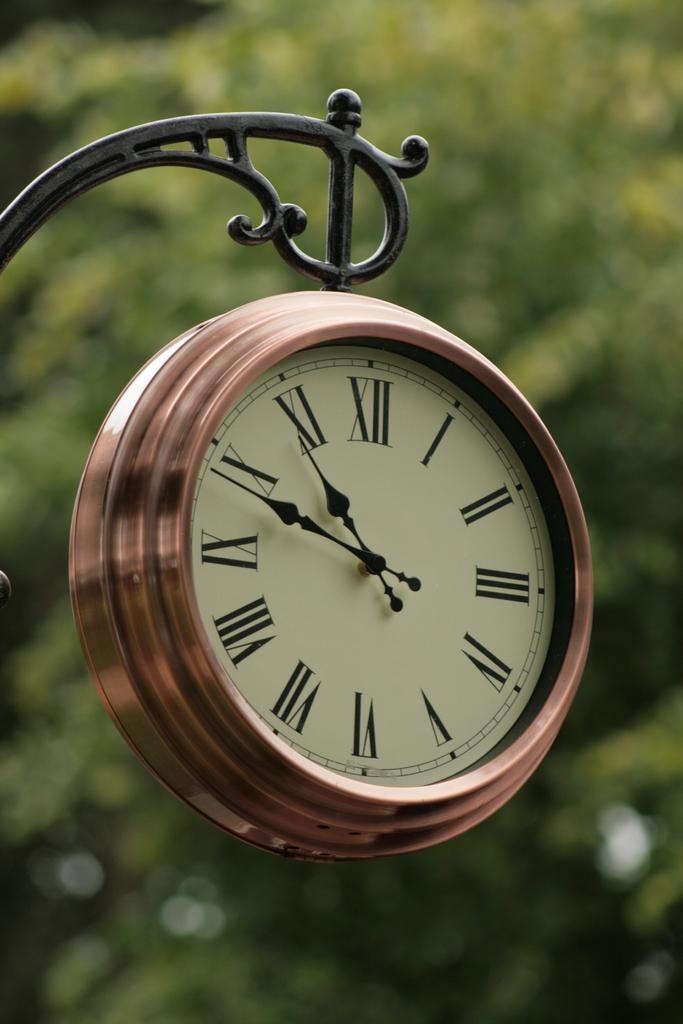Please provide a concise description of this image. In this image we can see a clock, hanging from a metal rod, in the background of the image there are trees. 